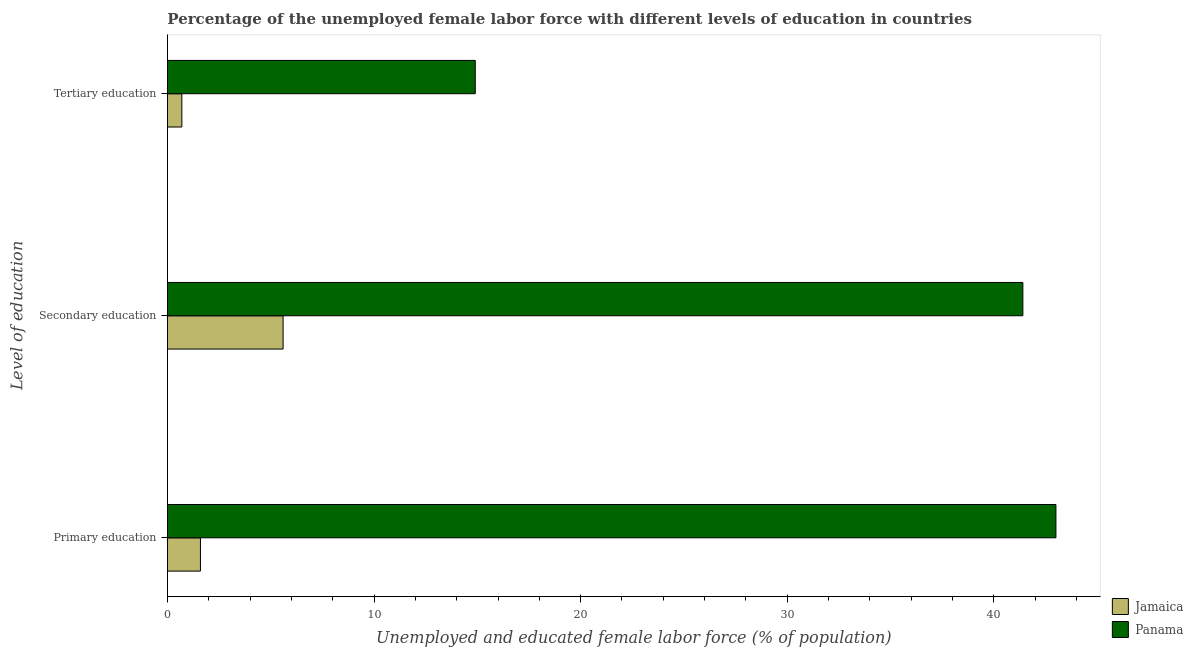Are the number of bars per tick equal to the number of legend labels?
Provide a succinct answer. Yes. Are the number of bars on each tick of the Y-axis equal?
Your answer should be compact. Yes. What is the label of the 3rd group of bars from the top?
Make the answer very short. Primary education. What is the percentage of female labor force who received secondary education in Jamaica?
Keep it short and to the point. 5.6. Across all countries, what is the maximum percentage of female labor force who received secondary education?
Your answer should be very brief. 41.4. Across all countries, what is the minimum percentage of female labor force who received secondary education?
Provide a short and direct response. 5.6. In which country was the percentage of female labor force who received secondary education maximum?
Give a very brief answer. Panama. In which country was the percentage of female labor force who received primary education minimum?
Your answer should be very brief. Jamaica. What is the total percentage of female labor force who received primary education in the graph?
Make the answer very short. 44.6. What is the difference between the percentage of female labor force who received primary education in Panama and that in Jamaica?
Your answer should be very brief. 41.4. What is the difference between the percentage of female labor force who received secondary education in Panama and the percentage of female labor force who received tertiary education in Jamaica?
Your response must be concise. 40.7. What is the average percentage of female labor force who received primary education per country?
Ensure brevity in your answer.  22.3. What is the difference between the percentage of female labor force who received primary education and percentage of female labor force who received tertiary education in Panama?
Offer a terse response. 28.1. In how many countries, is the percentage of female labor force who received secondary education greater than 24 %?
Provide a short and direct response. 1. What is the ratio of the percentage of female labor force who received tertiary education in Panama to that in Jamaica?
Your answer should be compact. 21.29. What is the difference between the highest and the second highest percentage of female labor force who received primary education?
Keep it short and to the point. 41.4. What is the difference between the highest and the lowest percentage of female labor force who received tertiary education?
Provide a short and direct response. 14.2. In how many countries, is the percentage of female labor force who received primary education greater than the average percentage of female labor force who received primary education taken over all countries?
Offer a terse response. 1. What does the 2nd bar from the top in Primary education represents?
Give a very brief answer. Jamaica. What does the 2nd bar from the bottom in Primary education represents?
Offer a terse response. Panama. Is it the case that in every country, the sum of the percentage of female labor force who received primary education and percentage of female labor force who received secondary education is greater than the percentage of female labor force who received tertiary education?
Keep it short and to the point. Yes. Are all the bars in the graph horizontal?
Your answer should be very brief. Yes. Are the values on the major ticks of X-axis written in scientific E-notation?
Ensure brevity in your answer.  No. Does the graph contain any zero values?
Your response must be concise. No. How many legend labels are there?
Ensure brevity in your answer.  2. How are the legend labels stacked?
Ensure brevity in your answer.  Vertical. What is the title of the graph?
Your answer should be very brief. Percentage of the unemployed female labor force with different levels of education in countries. Does "Belize" appear as one of the legend labels in the graph?
Make the answer very short. No. What is the label or title of the X-axis?
Your answer should be very brief. Unemployed and educated female labor force (% of population). What is the label or title of the Y-axis?
Your answer should be very brief. Level of education. What is the Unemployed and educated female labor force (% of population) in Jamaica in Primary education?
Offer a very short reply. 1.6. What is the Unemployed and educated female labor force (% of population) in Panama in Primary education?
Make the answer very short. 43. What is the Unemployed and educated female labor force (% of population) of Jamaica in Secondary education?
Offer a terse response. 5.6. What is the Unemployed and educated female labor force (% of population) of Panama in Secondary education?
Make the answer very short. 41.4. What is the Unemployed and educated female labor force (% of population) in Jamaica in Tertiary education?
Give a very brief answer. 0.7. What is the Unemployed and educated female labor force (% of population) of Panama in Tertiary education?
Offer a terse response. 14.9. Across all Level of education, what is the maximum Unemployed and educated female labor force (% of population) in Jamaica?
Your answer should be very brief. 5.6. Across all Level of education, what is the maximum Unemployed and educated female labor force (% of population) in Panama?
Offer a very short reply. 43. Across all Level of education, what is the minimum Unemployed and educated female labor force (% of population) of Jamaica?
Provide a short and direct response. 0.7. Across all Level of education, what is the minimum Unemployed and educated female labor force (% of population) of Panama?
Keep it short and to the point. 14.9. What is the total Unemployed and educated female labor force (% of population) of Panama in the graph?
Your answer should be compact. 99.3. What is the difference between the Unemployed and educated female labor force (% of population) in Jamaica in Primary education and that in Secondary education?
Provide a succinct answer. -4. What is the difference between the Unemployed and educated female labor force (% of population) of Jamaica in Primary education and that in Tertiary education?
Your answer should be very brief. 0.9. What is the difference between the Unemployed and educated female labor force (% of population) in Panama in Primary education and that in Tertiary education?
Offer a very short reply. 28.1. What is the difference between the Unemployed and educated female labor force (% of population) in Jamaica in Primary education and the Unemployed and educated female labor force (% of population) in Panama in Secondary education?
Offer a terse response. -39.8. What is the average Unemployed and educated female labor force (% of population) of Jamaica per Level of education?
Your response must be concise. 2.63. What is the average Unemployed and educated female labor force (% of population) in Panama per Level of education?
Your response must be concise. 33.1. What is the difference between the Unemployed and educated female labor force (% of population) of Jamaica and Unemployed and educated female labor force (% of population) of Panama in Primary education?
Your response must be concise. -41.4. What is the difference between the Unemployed and educated female labor force (% of population) in Jamaica and Unemployed and educated female labor force (% of population) in Panama in Secondary education?
Provide a succinct answer. -35.8. What is the ratio of the Unemployed and educated female labor force (% of population) of Jamaica in Primary education to that in Secondary education?
Give a very brief answer. 0.29. What is the ratio of the Unemployed and educated female labor force (% of population) in Panama in Primary education to that in Secondary education?
Offer a very short reply. 1.04. What is the ratio of the Unemployed and educated female labor force (% of population) of Jamaica in Primary education to that in Tertiary education?
Provide a short and direct response. 2.29. What is the ratio of the Unemployed and educated female labor force (% of population) of Panama in Primary education to that in Tertiary education?
Provide a short and direct response. 2.89. What is the ratio of the Unemployed and educated female labor force (% of population) of Jamaica in Secondary education to that in Tertiary education?
Offer a very short reply. 8. What is the ratio of the Unemployed and educated female labor force (% of population) in Panama in Secondary education to that in Tertiary education?
Your answer should be very brief. 2.78. What is the difference between the highest and the lowest Unemployed and educated female labor force (% of population) of Jamaica?
Your answer should be very brief. 4.9. What is the difference between the highest and the lowest Unemployed and educated female labor force (% of population) of Panama?
Provide a short and direct response. 28.1. 